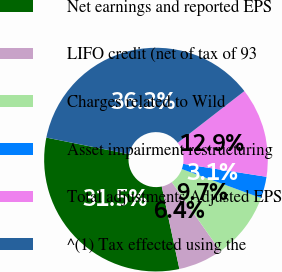Convert chart to OTSL. <chart><loc_0><loc_0><loc_500><loc_500><pie_chart><fcel>Net earnings and reported EPS<fcel>LIFO credit (net of tax of 93<fcel>Charges related to Wild<fcel>Asset impairment restructuring<fcel>Total adjustments Adjusted EPS<fcel>^(1) Tax effected using the<nl><fcel>31.51%<fcel>6.4%<fcel>9.67%<fcel>3.12%<fcel>12.95%<fcel>36.35%<nl></chart> 